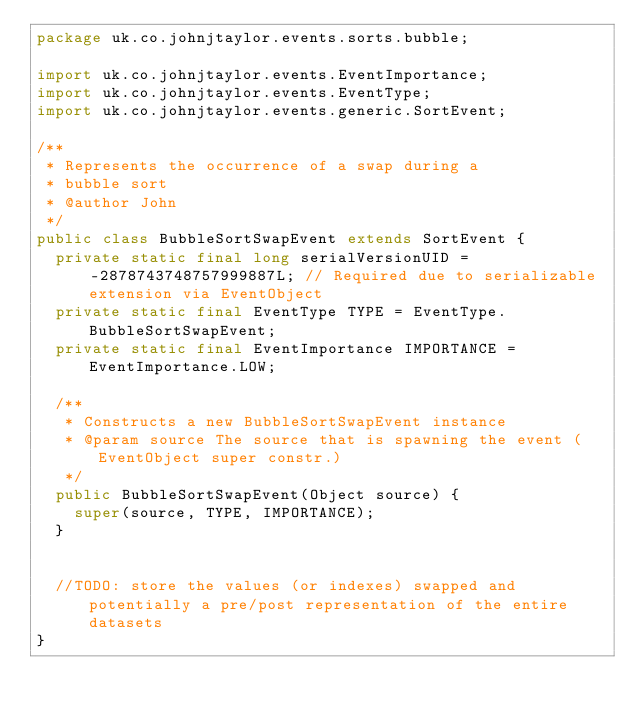Convert code to text. <code><loc_0><loc_0><loc_500><loc_500><_Java_>package uk.co.johnjtaylor.events.sorts.bubble;

import uk.co.johnjtaylor.events.EventImportance;
import uk.co.johnjtaylor.events.EventType;
import uk.co.johnjtaylor.events.generic.SortEvent;

/**
 * Represents the occurrence of a swap during a 
 * bubble sort
 * @author John
 */
public class BubbleSortSwapEvent extends SortEvent {
	private static final long serialVersionUID = -2878743748757999887L; // Required due to serializable extension via EventObject
	private static final EventType TYPE = EventType.BubbleSortSwapEvent;
	private static final EventImportance IMPORTANCE = EventImportance.LOW;

	/**
	 * Constructs a new BubbleSortSwapEvent instance
	 * @param source The source that is spawning the event (EventObject super constr.)
	 */
	public BubbleSortSwapEvent(Object source) {
		super(source, TYPE, IMPORTANCE);
	}

	
	//TODO: store the values (or indexes) swapped and potentially a pre/post representation of the entire datasets
}
</code> 